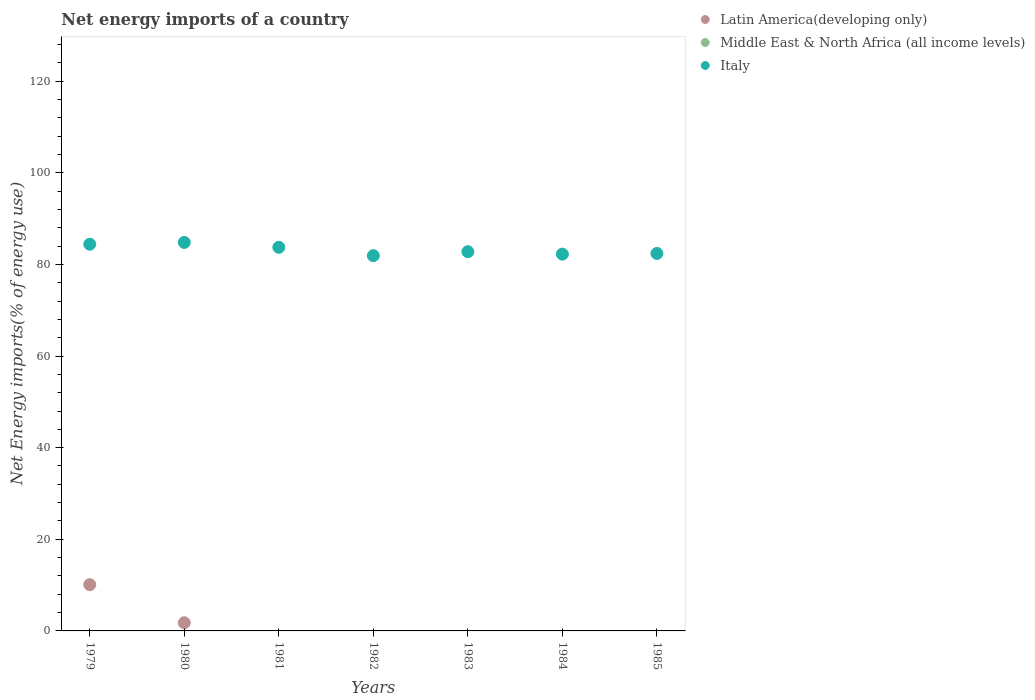Is the number of dotlines equal to the number of legend labels?
Provide a succinct answer. No. Across all years, what is the maximum net energy imports in Latin America(developing only)?
Ensure brevity in your answer.  10.1. In which year was the net energy imports in Latin America(developing only) maximum?
Your response must be concise. 1979. What is the total net energy imports in Latin America(developing only) in the graph?
Ensure brevity in your answer.  11.88. What is the difference between the net energy imports in Italy in 1982 and that in 1983?
Ensure brevity in your answer.  -0.87. What is the difference between the net energy imports in Italy in 1984 and the net energy imports in Latin America(developing only) in 1983?
Your answer should be compact. 82.24. What is the average net energy imports in Middle East & North Africa (all income levels) per year?
Your response must be concise. 0. In the year 1979, what is the difference between the net energy imports in Italy and net energy imports in Latin America(developing only)?
Provide a short and direct response. 74.3. In how many years, is the net energy imports in Latin America(developing only) greater than 120 %?
Give a very brief answer. 0. What is the ratio of the net energy imports in Italy in 1984 to that in 1985?
Your response must be concise. 1. What is the difference between the highest and the second highest net energy imports in Italy?
Provide a succinct answer. 0.39. What is the difference between the highest and the lowest net energy imports in Italy?
Provide a succinct answer. 2.89. Is the net energy imports in Latin America(developing only) strictly less than the net energy imports in Middle East & North Africa (all income levels) over the years?
Ensure brevity in your answer.  No. How many dotlines are there?
Give a very brief answer. 2. Are the values on the major ticks of Y-axis written in scientific E-notation?
Offer a very short reply. No. How many legend labels are there?
Make the answer very short. 3. How are the legend labels stacked?
Make the answer very short. Vertical. What is the title of the graph?
Keep it short and to the point. Net energy imports of a country. What is the label or title of the X-axis?
Your answer should be compact. Years. What is the label or title of the Y-axis?
Your response must be concise. Net Energy imports(% of energy use). What is the Net Energy imports(% of energy use) in Latin America(developing only) in 1979?
Your answer should be compact. 10.1. What is the Net Energy imports(% of energy use) of Italy in 1979?
Keep it short and to the point. 84.4. What is the Net Energy imports(% of energy use) of Latin America(developing only) in 1980?
Your answer should be compact. 1.78. What is the Net Energy imports(% of energy use) in Middle East & North Africa (all income levels) in 1980?
Provide a short and direct response. 0. What is the Net Energy imports(% of energy use) of Italy in 1980?
Keep it short and to the point. 84.79. What is the Net Energy imports(% of energy use) of Italy in 1981?
Give a very brief answer. 83.73. What is the Net Energy imports(% of energy use) in Middle East & North Africa (all income levels) in 1982?
Make the answer very short. 0. What is the Net Energy imports(% of energy use) in Italy in 1982?
Give a very brief answer. 81.91. What is the Net Energy imports(% of energy use) in Latin America(developing only) in 1983?
Your answer should be very brief. 0. What is the Net Energy imports(% of energy use) in Italy in 1983?
Your answer should be very brief. 82.77. What is the Net Energy imports(% of energy use) of Italy in 1984?
Offer a very short reply. 82.24. What is the Net Energy imports(% of energy use) in Latin America(developing only) in 1985?
Ensure brevity in your answer.  0. What is the Net Energy imports(% of energy use) of Middle East & North Africa (all income levels) in 1985?
Provide a succinct answer. 0. What is the Net Energy imports(% of energy use) in Italy in 1985?
Your answer should be compact. 82.39. Across all years, what is the maximum Net Energy imports(% of energy use) in Latin America(developing only)?
Offer a terse response. 10.1. Across all years, what is the maximum Net Energy imports(% of energy use) of Italy?
Your answer should be compact. 84.79. Across all years, what is the minimum Net Energy imports(% of energy use) of Italy?
Your answer should be compact. 81.91. What is the total Net Energy imports(% of energy use) in Latin America(developing only) in the graph?
Offer a very short reply. 11.88. What is the total Net Energy imports(% of energy use) in Middle East & North Africa (all income levels) in the graph?
Your answer should be compact. 0. What is the total Net Energy imports(% of energy use) of Italy in the graph?
Provide a short and direct response. 582.24. What is the difference between the Net Energy imports(% of energy use) of Latin America(developing only) in 1979 and that in 1980?
Offer a very short reply. 8.32. What is the difference between the Net Energy imports(% of energy use) in Italy in 1979 and that in 1980?
Offer a terse response. -0.39. What is the difference between the Net Energy imports(% of energy use) in Italy in 1979 and that in 1981?
Your answer should be compact. 0.67. What is the difference between the Net Energy imports(% of energy use) in Italy in 1979 and that in 1982?
Ensure brevity in your answer.  2.49. What is the difference between the Net Energy imports(% of energy use) in Italy in 1979 and that in 1983?
Your response must be concise. 1.63. What is the difference between the Net Energy imports(% of energy use) in Italy in 1979 and that in 1984?
Your answer should be compact. 2.16. What is the difference between the Net Energy imports(% of energy use) in Italy in 1979 and that in 1985?
Provide a short and direct response. 2.01. What is the difference between the Net Energy imports(% of energy use) of Italy in 1980 and that in 1981?
Make the answer very short. 1.06. What is the difference between the Net Energy imports(% of energy use) in Italy in 1980 and that in 1982?
Provide a short and direct response. 2.89. What is the difference between the Net Energy imports(% of energy use) of Italy in 1980 and that in 1983?
Your answer should be very brief. 2.02. What is the difference between the Net Energy imports(% of energy use) of Italy in 1980 and that in 1984?
Keep it short and to the point. 2.55. What is the difference between the Net Energy imports(% of energy use) in Italy in 1980 and that in 1985?
Provide a succinct answer. 2.4. What is the difference between the Net Energy imports(% of energy use) of Italy in 1981 and that in 1982?
Provide a succinct answer. 1.82. What is the difference between the Net Energy imports(% of energy use) of Italy in 1981 and that in 1983?
Provide a short and direct response. 0.96. What is the difference between the Net Energy imports(% of energy use) in Italy in 1981 and that in 1984?
Keep it short and to the point. 1.49. What is the difference between the Net Energy imports(% of energy use) of Italy in 1981 and that in 1985?
Give a very brief answer. 1.34. What is the difference between the Net Energy imports(% of energy use) in Italy in 1982 and that in 1983?
Give a very brief answer. -0.87. What is the difference between the Net Energy imports(% of energy use) in Italy in 1982 and that in 1984?
Your answer should be compact. -0.34. What is the difference between the Net Energy imports(% of energy use) in Italy in 1982 and that in 1985?
Ensure brevity in your answer.  -0.48. What is the difference between the Net Energy imports(% of energy use) in Italy in 1983 and that in 1984?
Provide a succinct answer. 0.53. What is the difference between the Net Energy imports(% of energy use) of Italy in 1983 and that in 1985?
Your answer should be very brief. 0.38. What is the difference between the Net Energy imports(% of energy use) in Italy in 1984 and that in 1985?
Offer a terse response. -0.15. What is the difference between the Net Energy imports(% of energy use) in Latin America(developing only) in 1979 and the Net Energy imports(% of energy use) in Italy in 1980?
Provide a succinct answer. -74.7. What is the difference between the Net Energy imports(% of energy use) of Latin America(developing only) in 1979 and the Net Energy imports(% of energy use) of Italy in 1981?
Your answer should be very brief. -73.63. What is the difference between the Net Energy imports(% of energy use) in Latin America(developing only) in 1979 and the Net Energy imports(% of energy use) in Italy in 1982?
Your answer should be compact. -71.81. What is the difference between the Net Energy imports(% of energy use) of Latin America(developing only) in 1979 and the Net Energy imports(% of energy use) of Italy in 1983?
Ensure brevity in your answer.  -72.67. What is the difference between the Net Energy imports(% of energy use) of Latin America(developing only) in 1979 and the Net Energy imports(% of energy use) of Italy in 1984?
Your answer should be compact. -72.14. What is the difference between the Net Energy imports(% of energy use) in Latin America(developing only) in 1979 and the Net Energy imports(% of energy use) in Italy in 1985?
Offer a very short reply. -72.29. What is the difference between the Net Energy imports(% of energy use) in Latin America(developing only) in 1980 and the Net Energy imports(% of energy use) in Italy in 1981?
Offer a terse response. -81.95. What is the difference between the Net Energy imports(% of energy use) in Latin America(developing only) in 1980 and the Net Energy imports(% of energy use) in Italy in 1982?
Offer a terse response. -80.12. What is the difference between the Net Energy imports(% of energy use) in Latin America(developing only) in 1980 and the Net Energy imports(% of energy use) in Italy in 1983?
Ensure brevity in your answer.  -80.99. What is the difference between the Net Energy imports(% of energy use) in Latin America(developing only) in 1980 and the Net Energy imports(% of energy use) in Italy in 1984?
Offer a very short reply. -80.46. What is the difference between the Net Energy imports(% of energy use) of Latin America(developing only) in 1980 and the Net Energy imports(% of energy use) of Italy in 1985?
Ensure brevity in your answer.  -80.61. What is the average Net Energy imports(% of energy use) of Latin America(developing only) per year?
Keep it short and to the point. 1.7. What is the average Net Energy imports(% of energy use) of Italy per year?
Your response must be concise. 83.18. In the year 1979, what is the difference between the Net Energy imports(% of energy use) in Latin America(developing only) and Net Energy imports(% of energy use) in Italy?
Your answer should be very brief. -74.3. In the year 1980, what is the difference between the Net Energy imports(% of energy use) in Latin America(developing only) and Net Energy imports(% of energy use) in Italy?
Offer a terse response. -83.01. What is the ratio of the Net Energy imports(% of energy use) in Latin America(developing only) in 1979 to that in 1980?
Your response must be concise. 5.66. What is the ratio of the Net Energy imports(% of energy use) of Italy in 1979 to that in 1980?
Ensure brevity in your answer.  1. What is the ratio of the Net Energy imports(% of energy use) of Italy in 1979 to that in 1981?
Your answer should be very brief. 1.01. What is the ratio of the Net Energy imports(% of energy use) of Italy in 1979 to that in 1982?
Your response must be concise. 1.03. What is the ratio of the Net Energy imports(% of energy use) of Italy in 1979 to that in 1983?
Provide a succinct answer. 1.02. What is the ratio of the Net Energy imports(% of energy use) in Italy in 1979 to that in 1984?
Offer a very short reply. 1.03. What is the ratio of the Net Energy imports(% of energy use) in Italy in 1979 to that in 1985?
Provide a short and direct response. 1.02. What is the ratio of the Net Energy imports(% of energy use) of Italy in 1980 to that in 1981?
Offer a very short reply. 1.01. What is the ratio of the Net Energy imports(% of energy use) of Italy in 1980 to that in 1982?
Keep it short and to the point. 1.04. What is the ratio of the Net Energy imports(% of energy use) of Italy in 1980 to that in 1983?
Your response must be concise. 1.02. What is the ratio of the Net Energy imports(% of energy use) in Italy in 1980 to that in 1984?
Ensure brevity in your answer.  1.03. What is the ratio of the Net Energy imports(% of energy use) in Italy in 1980 to that in 1985?
Give a very brief answer. 1.03. What is the ratio of the Net Energy imports(% of energy use) of Italy in 1981 to that in 1982?
Your answer should be very brief. 1.02. What is the ratio of the Net Energy imports(% of energy use) in Italy in 1981 to that in 1983?
Your response must be concise. 1.01. What is the ratio of the Net Energy imports(% of energy use) of Italy in 1981 to that in 1984?
Offer a very short reply. 1.02. What is the ratio of the Net Energy imports(% of energy use) of Italy in 1981 to that in 1985?
Your answer should be very brief. 1.02. What is the ratio of the Net Energy imports(% of energy use) of Italy in 1982 to that in 1983?
Your response must be concise. 0.99. What is the ratio of the Net Energy imports(% of energy use) in Italy in 1982 to that in 1985?
Offer a very short reply. 0.99. What is the ratio of the Net Energy imports(% of energy use) of Italy in 1983 to that in 1984?
Ensure brevity in your answer.  1.01. What is the ratio of the Net Energy imports(% of energy use) in Italy in 1983 to that in 1985?
Your response must be concise. 1. What is the difference between the highest and the second highest Net Energy imports(% of energy use) of Italy?
Give a very brief answer. 0.39. What is the difference between the highest and the lowest Net Energy imports(% of energy use) in Latin America(developing only)?
Your response must be concise. 10.1. What is the difference between the highest and the lowest Net Energy imports(% of energy use) in Italy?
Your answer should be very brief. 2.89. 